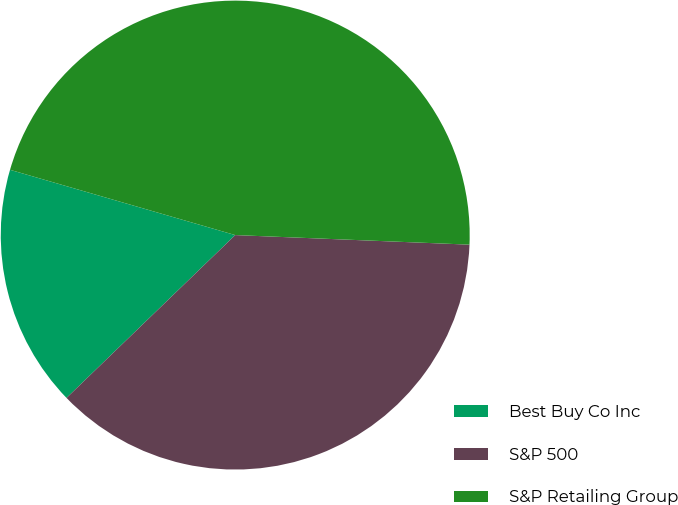<chart> <loc_0><loc_0><loc_500><loc_500><pie_chart><fcel>Best Buy Co Inc<fcel>S&P 500<fcel>S&P Retailing Group<nl><fcel>16.71%<fcel>37.13%<fcel>46.16%<nl></chart> 